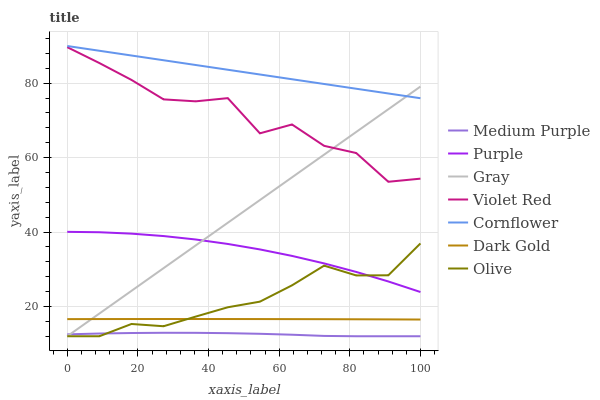Does Medium Purple have the minimum area under the curve?
Answer yes or no. Yes. Does Cornflower have the maximum area under the curve?
Answer yes or no. Yes. Does Violet Red have the minimum area under the curve?
Answer yes or no. No. Does Violet Red have the maximum area under the curve?
Answer yes or no. No. Is Cornflower the smoothest?
Answer yes or no. Yes. Is Violet Red the roughest?
Answer yes or no. Yes. Is Dark Gold the smoothest?
Answer yes or no. No. Is Dark Gold the roughest?
Answer yes or no. No. Does Medium Purple have the lowest value?
Answer yes or no. Yes. Does Violet Red have the lowest value?
Answer yes or no. No. Does Cornflower have the highest value?
Answer yes or no. Yes. Does Violet Red have the highest value?
Answer yes or no. No. Is Violet Red less than Cornflower?
Answer yes or no. Yes. Is Violet Red greater than Dark Gold?
Answer yes or no. Yes. Does Gray intersect Olive?
Answer yes or no. Yes. Is Gray less than Olive?
Answer yes or no. No. Is Gray greater than Olive?
Answer yes or no. No. Does Violet Red intersect Cornflower?
Answer yes or no. No. 